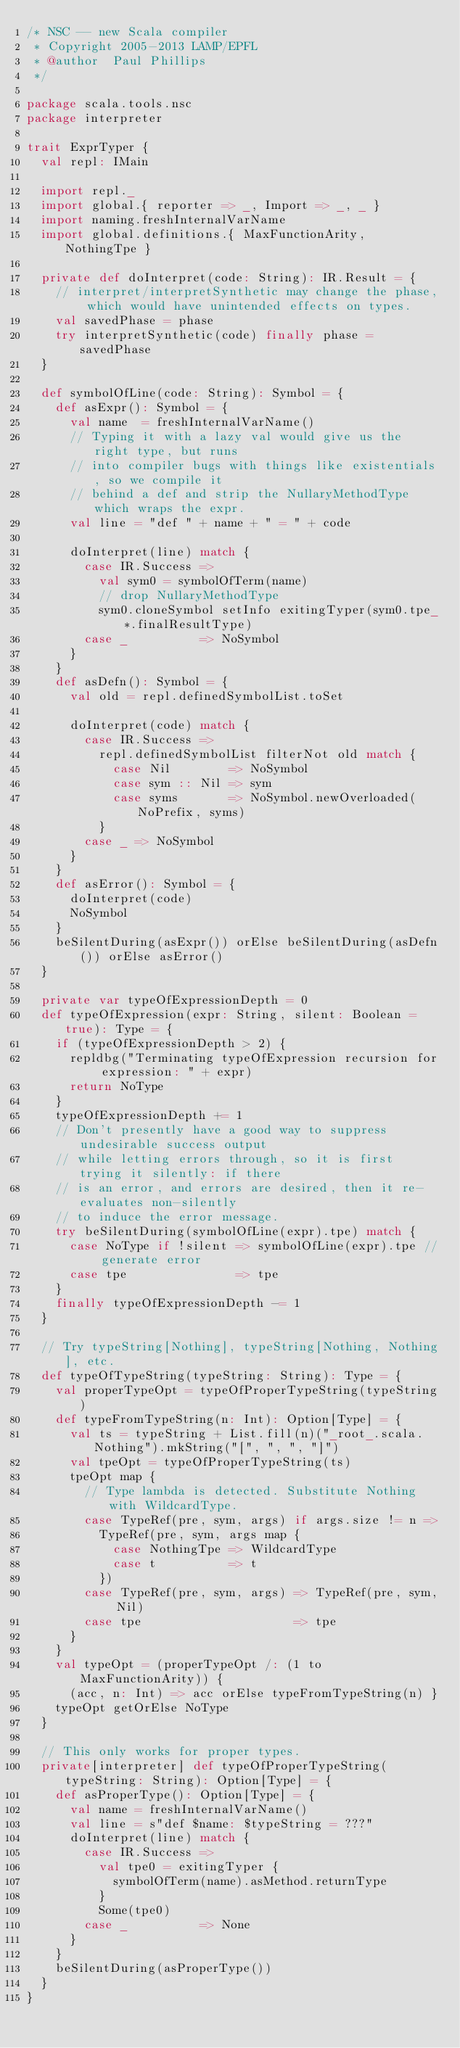Convert code to text. <code><loc_0><loc_0><loc_500><loc_500><_Scala_>/* NSC -- new Scala compiler
 * Copyright 2005-2013 LAMP/EPFL
 * @author  Paul Phillips
 */

package scala.tools.nsc
package interpreter

trait ExprTyper {
  val repl: IMain

  import repl._
  import global.{ reporter => _, Import => _, _ }
  import naming.freshInternalVarName
  import global.definitions.{ MaxFunctionArity, NothingTpe }

  private def doInterpret(code: String): IR.Result = {
    // interpret/interpretSynthetic may change the phase, which would have unintended effects on types.
    val savedPhase = phase
    try interpretSynthetic(code) finally phase = savedPhase
  }

  def symbolOfLine(code: String): Symbol = {
    def asExpr(): Symbol = {
      val name  = freshInternalVarName()
      // Typing it with a lazy val would give us the right type, but runs
      // into compiler bugs with things like existentials, so we compile it
      // behind a def and strip the NullaryMethodType which wraps the expr.
      val line = "def " + name + " = " + code

      doInterpret(line) match {
        case IR.Success =>
          val sym0 = symbolOfTerm(name)
          // drop NullaryMethodType
          sym0.cloneSymbol setInfo exitingTyper(sym0.tpe_*.finalResultType)
        case _          => NoSymbol
      }
    }
    def asDefn(): Symbol = {
      val old = repl.definedSymbolList.toSet

      doInterpret(code) match {
        case IR.Success =>
          repl.definedSymbolList filterNot old match {
            case Nil        => NoSymbol
            case sym :: Nil => sym
            case syms       => NoSymbol.newOverloaded(NoPrefix, syms)
          }
        case _ => NoSymbol
      }
    }
    def asError(): Symbol = {
      doInterpret(code)
      NoSymbol
    }
    beSilentDuring(asExpr()) orElse beSilentDuring(asDefn()) orElse asError()
  }

  private var typeOfExpressionDepth = 0
  def typeOfExpression(expr: String, silent: Boolean = true): Type = {
    if (typeOfExpressionDepth > 2) {
      repldbg("Terminating typeOfExpression recursion for expression: " + expr)
      return NoType
    }
    typeOfExpressionDepth += 1
    // Don't presently have a good way to suppress undesirable success output
    // while letting errors through, so it is first trying it silently: if there
    // is an error, and errors are desired, then it re-evaluates non-silently
    // to induce the error message.
    try beSilentDuring(symbolOfLine(expr).tpe) match {
      case NoType if !silent => symbolOfLine(expr).tpe // generate error
      case tpe               => tpe
    }
    finally typeOfExpressionDepth -= 1
  }

  // Try typeString[Nothing], typeString[Nothing, Nothing], etc.
  def typeOfTypeString(typeString: String): Type = {
    val properTypeOpt = typeOfProperTypeString(typeString)
    def typeFromTypeString(n: Int): Option[Type] = {
      val ts = typeString + List.fill(n)("_root_.scala.Nothing").mkString("[", ", ", "]")
      val tpeOpt = typeOfProperTypeString(ts)
      tpeOpt map {
        // Type lambda is detected. Substitute Nothing with WildcardType.
        case TypeRef(pre, sym, args) if args.size != n =>
          TypeRef(pre, sym, args map {
            case NothingTpe => WildcardType
            case t          => t
          })
        case TypeRef(pre, sym, args) => TypeRef(pre, sym, Nil)
        case tpe                     => tpe
      }
    }
    val typeOpt = (properTypeOpt /: (1 to MaxFunctionArity)) {
      (acc, n: Int) => acc orElse typeFromTypeString(n) }
    typeOpt getOrElse NoType
  }

  // This only works for proper types.
  private[interpreter] def typeOfProperTypeString(typeString: String): Option[Type] = {
    def asProperType(): Option[Type] = {
      val name = freshInternalVarName()
      val line = s"def $name: $typeString = ???"
      doInterpret(line) match {
        case IR.Success =>
          val tpe0 = exitingTyper {
            symbolOfTerm(name).asMethod.returnType
          }
          Some(tpe0)
        case _          => None
      }
    }
    beSilentDuring(asProperType())
  }
}
</code> 